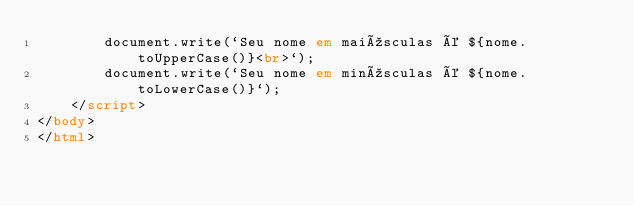Convert code to text. <code><loc_0><loc_0><loc_500><loc_500><_HTML_>        document.write(`Seu nome em maiúsculas é ${nome.toUpperCase()}<br>`);
        document.write(`Seu nome em minúsculas é ${nome.toLowerCase()}`);
    </script>
</body>
</html></code> 